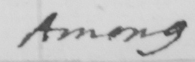What is written in this line of handwriting? Among 